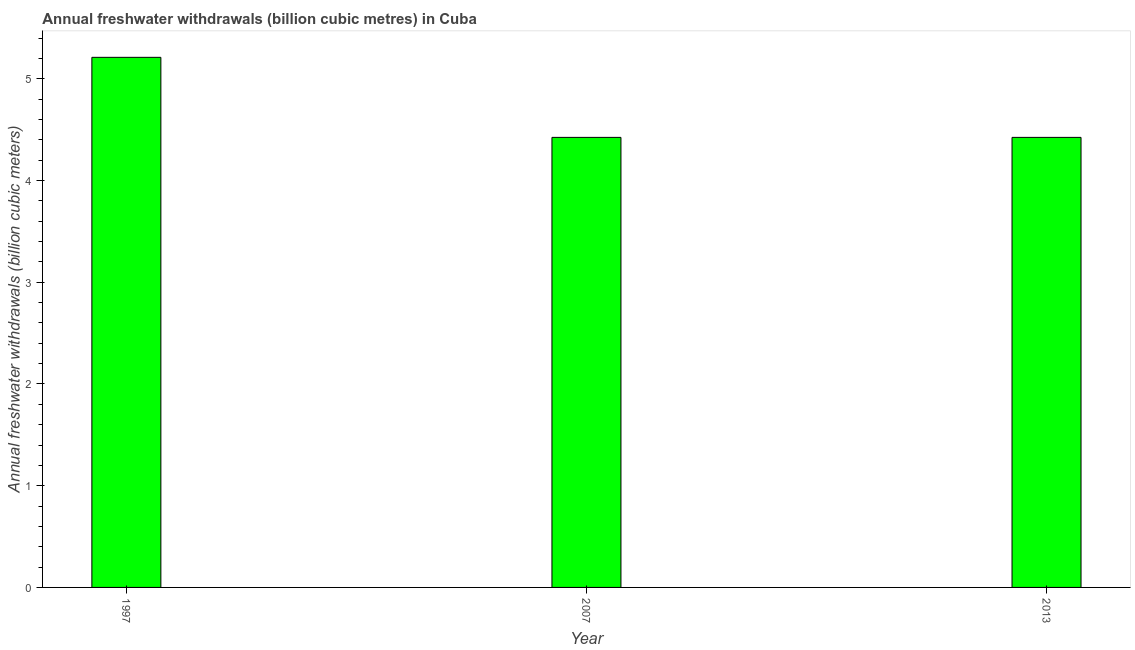Does the graph contain any zero values?
Offer a very short reply. No. Does the graph contain grids?
Provide a succinct answer. No. What is the title of the graph?
Make the answer very short. Annual freshwater withdrawals (billion cubic metres) in Cuba. What is the label or title of the X-axis?
Ensure brevity in your answer.  Year. What is the label or title of the Y-axis?
Offer a very short reply. Annual freshwater withdrawals (billion cubic meters). What is the annual freshwater withdrawals in 2007?
Offer a very short reply. 4.42. Across all years, what is the maximum annual freshwater withdrawals?
Make the answer very short. 5.21. Across all years, what is the minimum annual freshwater withdrawals?
Give a very brief answer. 4.42. In which year was the annual freshwater withdrawals maximum?
Provide a short and direct response. 1997. In which year was the annual freshwater withdrawals minimum?
Keep it short and to the point. 2007. What is the sum of the annual freshwater withdrawals?
Your response must be concise. 14.06. What is the difference between the annual freshwater withdrawals in 2007 and 2013?
Your answer should be compact. 0. What is the average annual freshwater withdrawals per year?
Offer a very short reply. 4.69. What is the median annual freshwater withdrawals?
Offer a terse response. 4.42. What is the ratio of the annual freshwater withdrawals in 1997 to that in 2007?
Your response must be concise. 1.18. Is the difference between the annual freshwater withdrawals in 1997 and 2013 greater than the difference between any two years?
Your answer should be compact. Yes. What is the difference between the highest and the second highest annual freshwater withdrawals?
Ensure brevity in your answer.  0.79. What is the difference between the highest and the lowest annual freshwater withdrawals?
Your answer should be very brief. 0.79. Are all the bars in the graph horizontal?
Your answer should be compact. No. How many years are there in the graph?
Your response must be concise. 3. Are the values on the major ticks of Y-axis written in scientific E-notation?
Make the answer very short. No. What is the Annual freshwater withdrawals (billion cubic meters) in 1997?
Your answer should be very brief. 5.21. What is the Annual freshwater withdrawals (billion cubic meters) of 2007?
Offer a terse response. 4.42. What is the Annual freshwater withdrawals (billion cubic meters) in 2013?
Offer a terse response. 4.42. What is the difference between the Annual freshwater withdrawals (billion cubic meters) in 1997 and 2007?
Give a very brief answer. 0.79. What is the difference between the Annual freshwater withdrawals (billion cubic meters) in 1997 and 2013?
Provide a succinct answer. 0.79. What is the difference between the Annual freshwater withdrawals (billion cubic meters) in 2007 and 2013?
Offer a terse response. 0. What is the ratio of the Annual freshwater withdrawals (billion cubic meters) in 1997 to that in 2007?
Your answer should be compact. 1.18. What is the ratio of the Annual freshwater withdrawals (billion cubic meters) in 1997 to that in 2013?
Your answer should be compact. 1.18. What is the ratio of the Annual freshwater withdrawals (billion cubic meters) in 2007 to that in 2013?
Your response must be concise. 1. 